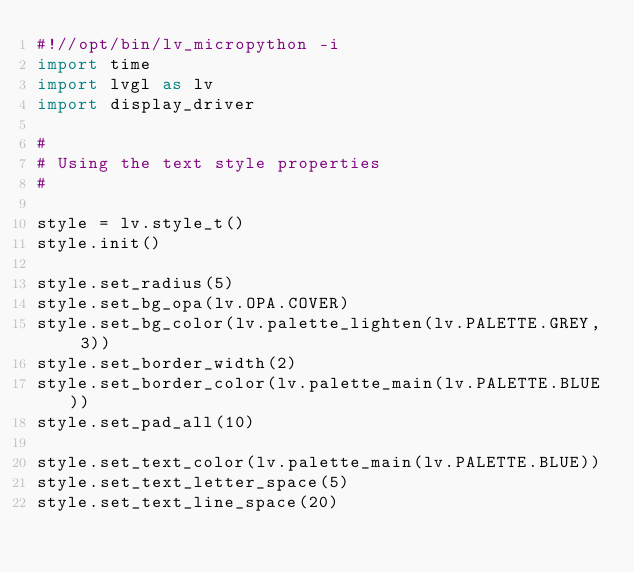Convert code to text. <code><loc_0><loc_0><loc_500><loc_500><_Python_>#!//opt/bin/lv_micropython -i
import time
import lvgl as lv
import display_driver

#
# Using the text style properties
#

style = lv.style_t()
style.init()

style.set_radius(5)
style.set_bg_opa(lv.OPA.COVER)
style.set_bg_color(lv.palette_lighten(lv.PALETTE.GREY, 3))
style.set_border_width(2)
style.set_border_color(lv.palette_main(lv.PALETTE.BLUE))
style.set_pad_all(10)

style.set_text_color(lv.palette_main(lv.PALETTE.BLUE))
style.set_text_letter_space(5)
style.set_text_line_space(20)</code> 